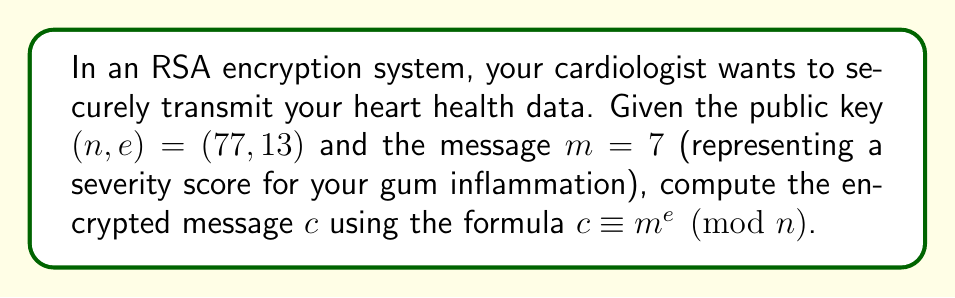Give your solution to this math problem. To compute the modular exponentiation for RSA encryption, we need to follow these steps:

1) We have $m = 7$, $e = 13$, and $n = 77$.

2) We need to calculate $c \equiv 7^{13} \pmod{77}$.

3) To efficiently compute this, we can use the square-and-multiply algorithm:

   $7^1 \equiv 7 \pmod{77}$
   $7^2 \equiv 49 \pmod{77}$
   $7^4 \equiv 49^2 \equiv 16 \pmod{77}$
   $7^8 \equiv 16^2 \equiv 25 \pmod{77}$

4) Now, we can express 13 in binary: $13 = 1101_2$

5) This means $7^{13} = 7^8 \cdot 7^4 \cdot 7^1$

6) Using the results from step 3:

   $7^{13} \equiv 25 \cdot 16 \cdot 7 \pmod{77}$

7) Compute step by step:
   
   $25 \cdot 16 \equiv 15 \pmod{77}$
   $15 \cdot 7 \equiv 28 \pmod{77}$

Therefore, $c \equiv 7^{13} \equiv 28 \pmod{77}$.
Answer: $28$ 